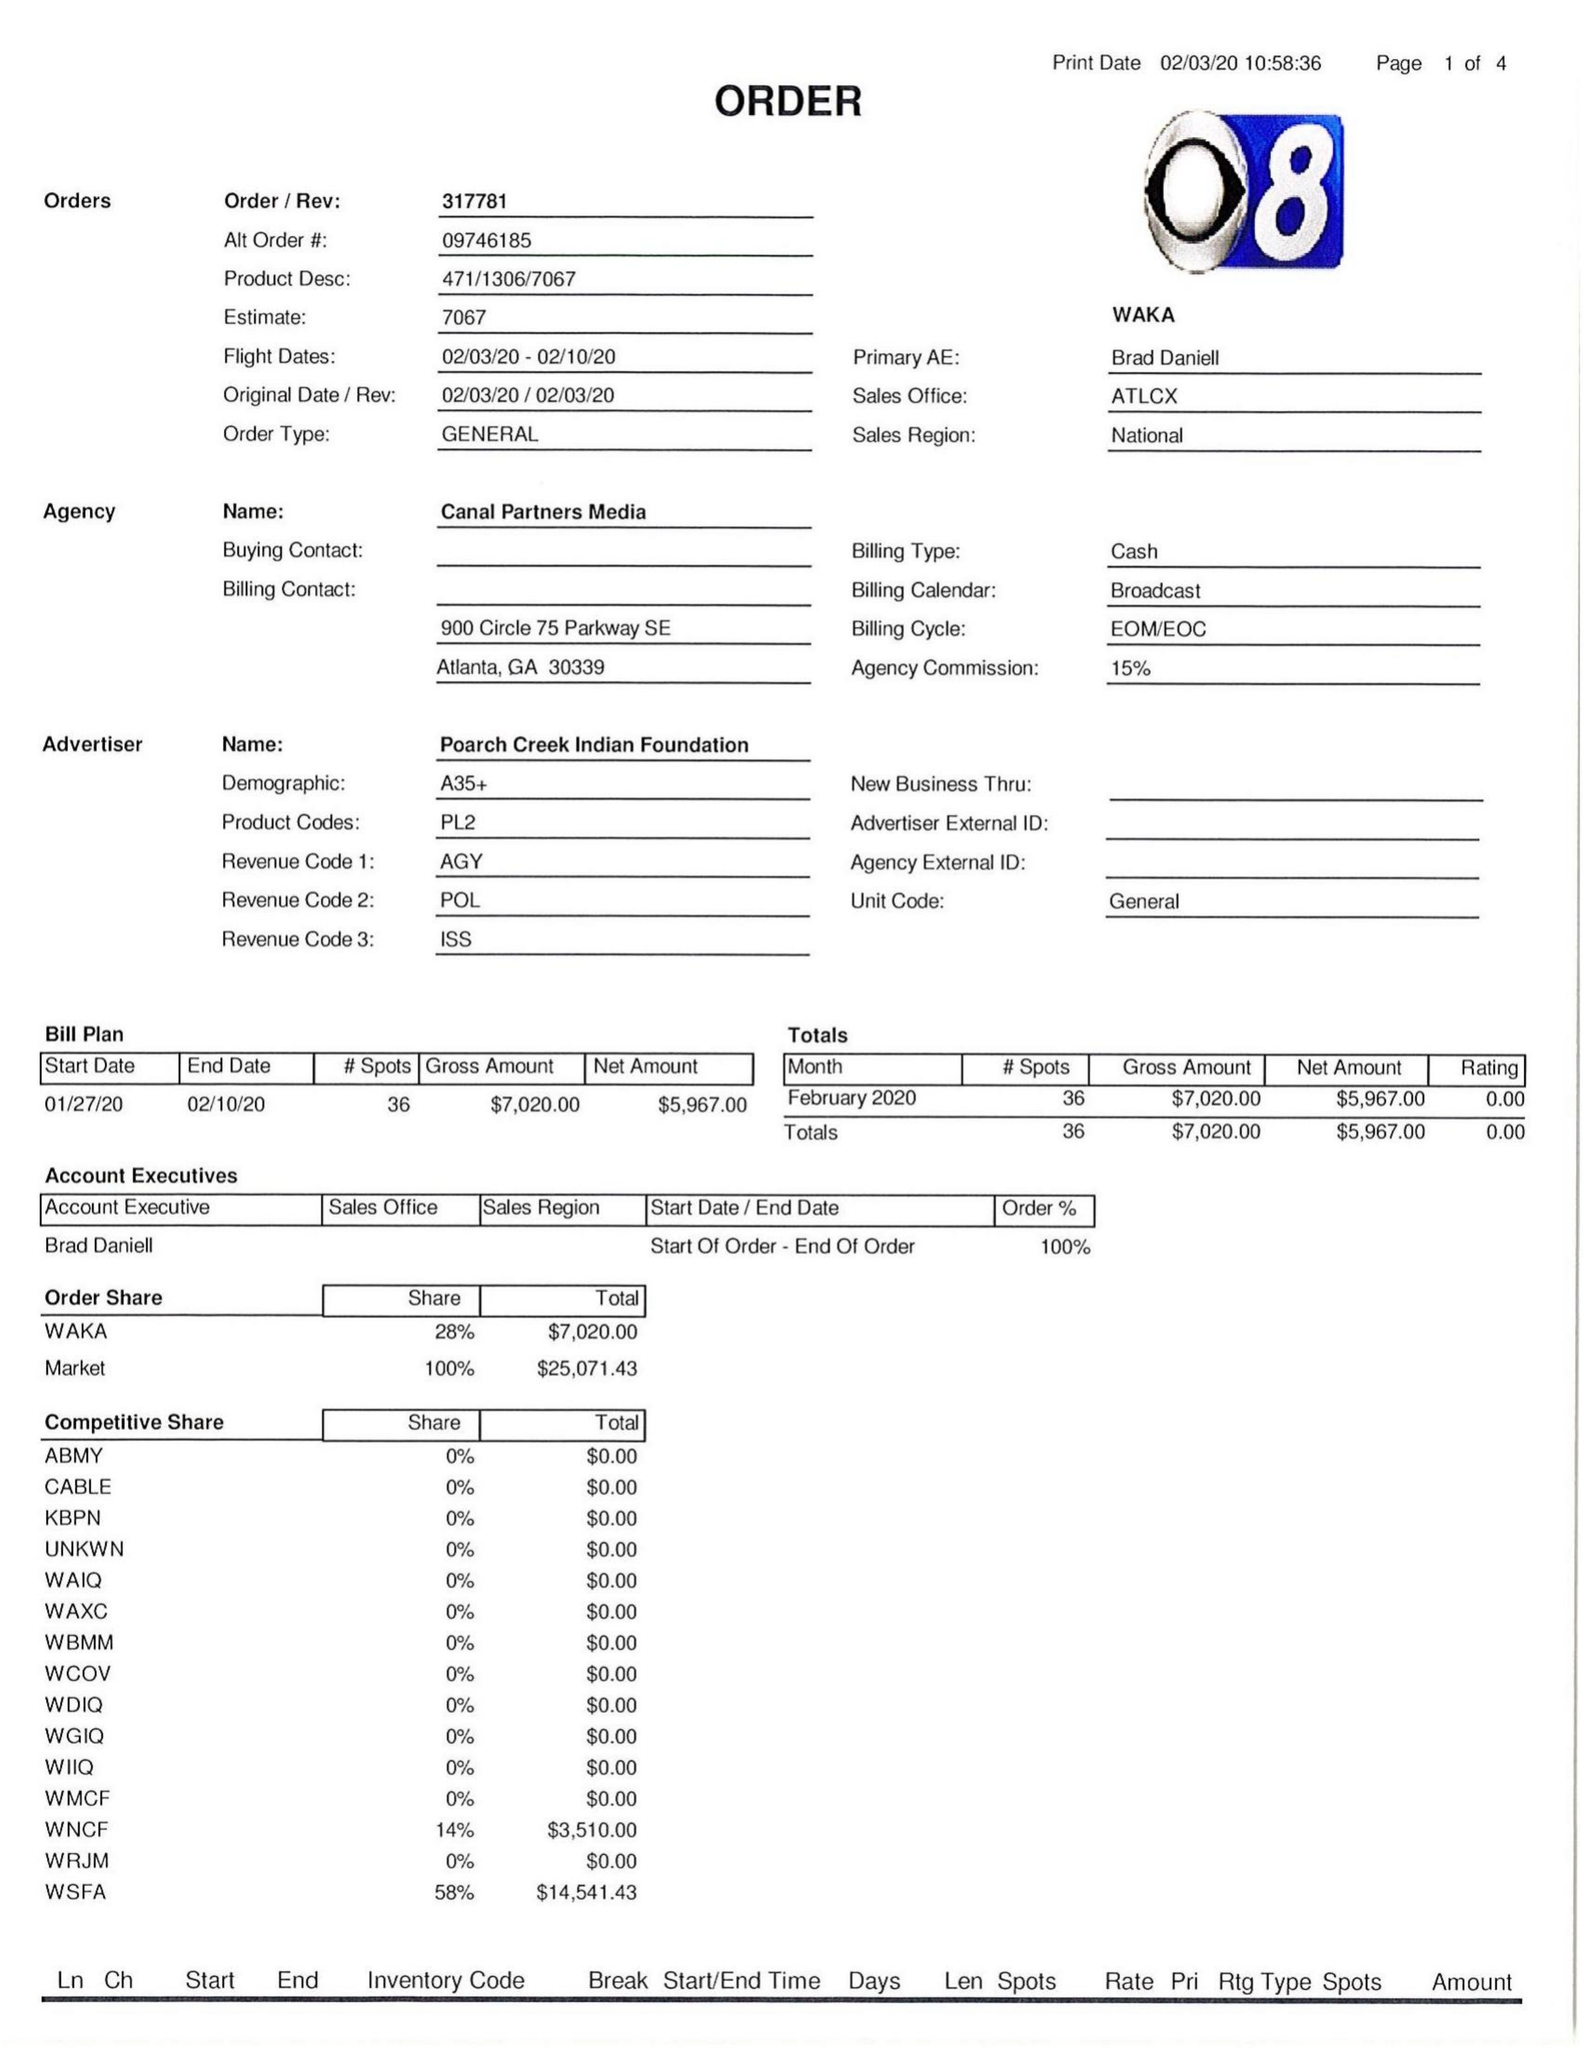What is the value for the flight_to?
Answer the question using a single word or phrase. 02/10/20 